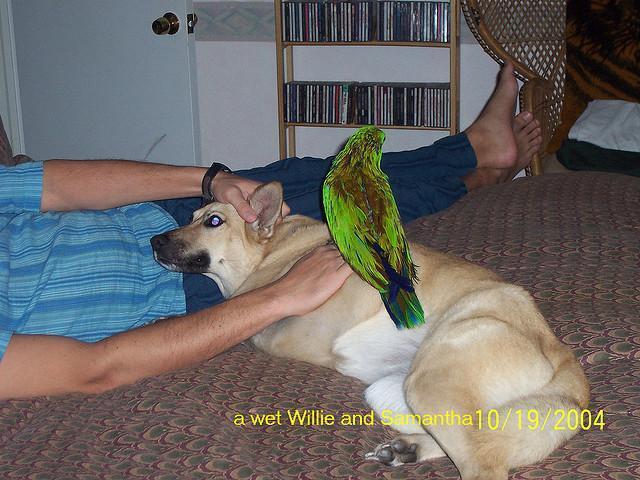How many animals are in this pick?
Give a very brief answer. 2. How many people can you see?
Give a very brief answer. 1. 